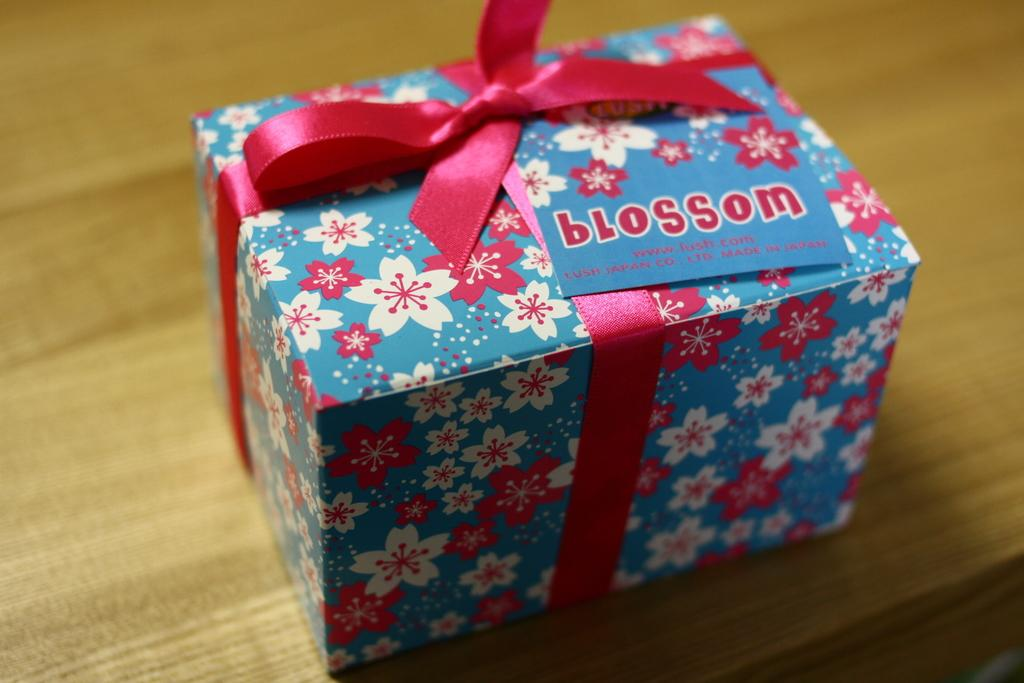What is the main object in the image? There is a gift box in the image. Is there anything attached to the gift box? Yes, there is a card on the gift box. What type of ribbon is on the gift box? There is a pink ribbon on the gift box. On what surface is the gift box placed? The gift box is placed on a wooden table. What type of tax is being discussed on the card attached to the gift box? There is no mention of tax on the card attached to the gift box. The image does not contain any information about taxes. 